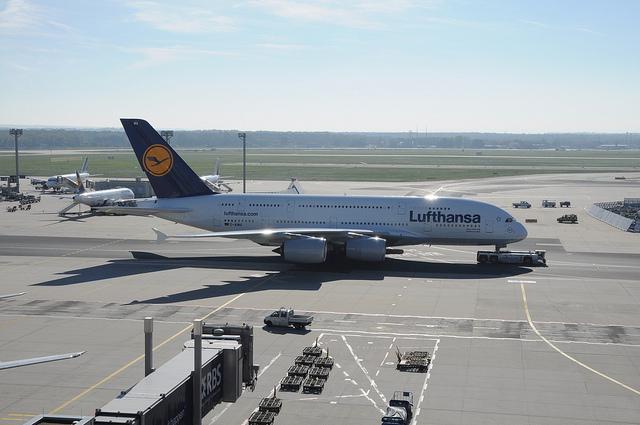Where is the plane located?
Write a very short answer. Airport. What word is on the plane?
Short answer required. Lufthansa. Is this an airstrip?
Be succinct. Yes. 